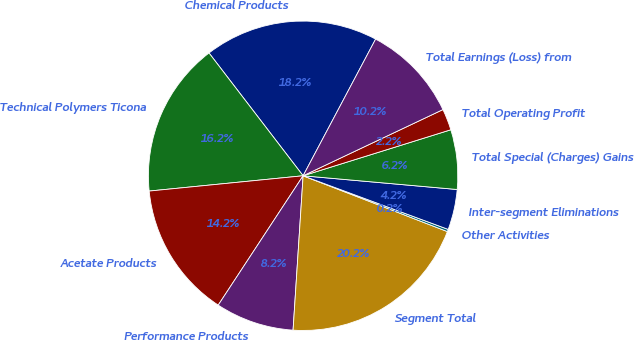Convert chart. <chart><loc_0><loc_0><loc_500><loc_500><pie_chart><fcel>Chemical Products<fcel>Technical Polymers Ticona<fcel>Acetate Products<fcel>Performance Products<fcel>Segment Total<fcel>Other Activities<fcel>Inter-segment Eliminations<fcel>Total Special (Charges) Gains<fcel>Total Operating Profit<fcel>Total Earnings (Loss) from<nl><fcel>18.17%<fcel>16.17%<fcel>14.18%<fcel>8.21%<fcel>20.16%<fcel>0.24%<fcel>4.22%<fcel>6.22%<fcel>2.23%<fcel>10.2%<nl></chart> 